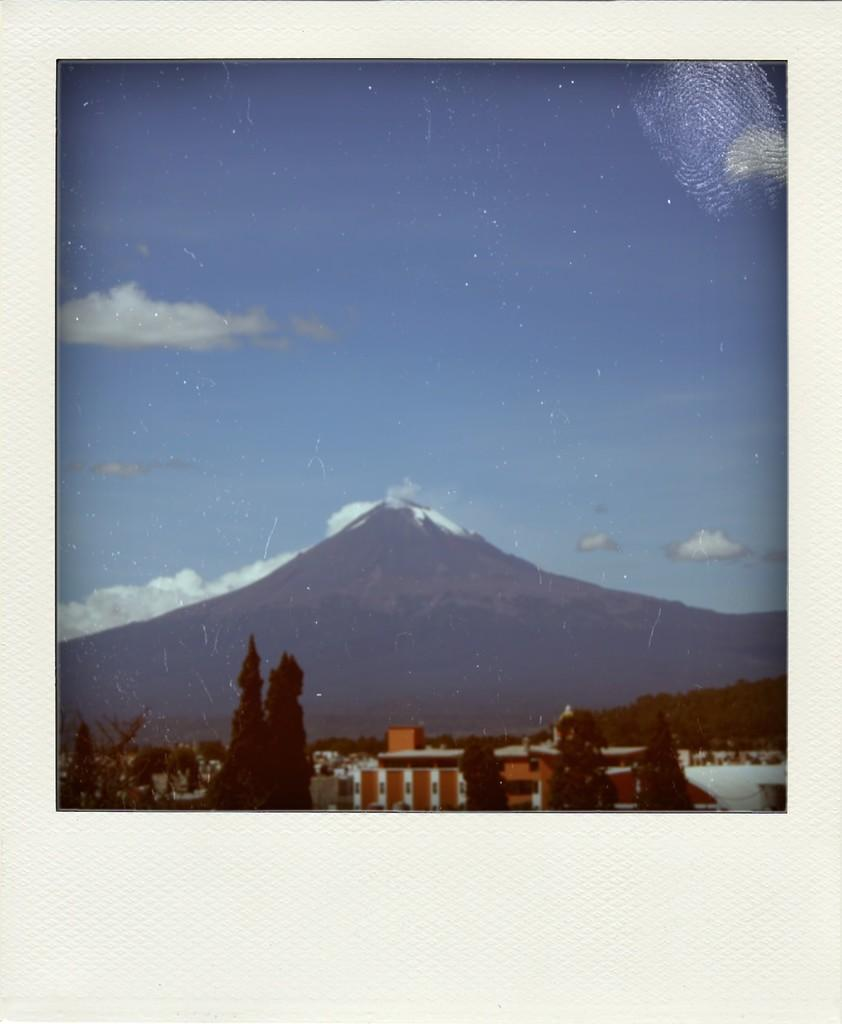What is the main subject of the image? The image contains a photograph. What can be seen in the center of the photograph? There is a hill in the center of the photograph. What structures are located at the bottom of the photograph? There are buildings at the bottom of the photograph. What type of vegetation is present at the bottom of the photograph? There are trees at the bottom of the photograph. What is visible at the top of the photograph? The sky is visible at the top of the photograph. What type of sock is hanging on the tree in the photograph? There is no sock present in the photograph; it features a hill, buildings, trees, and the sky. What hobbies are the people in the photograph engaged in? There are no people visible in the photograph, so their hobbies cannot be determined. 